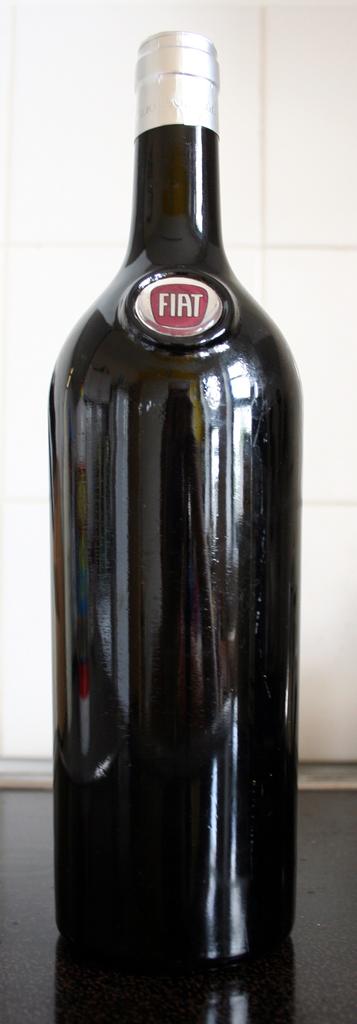What brand is the bottle?
Offer a terse response. Fiat. What is inside this bottle?
Your answer should be compact. Fiat. 